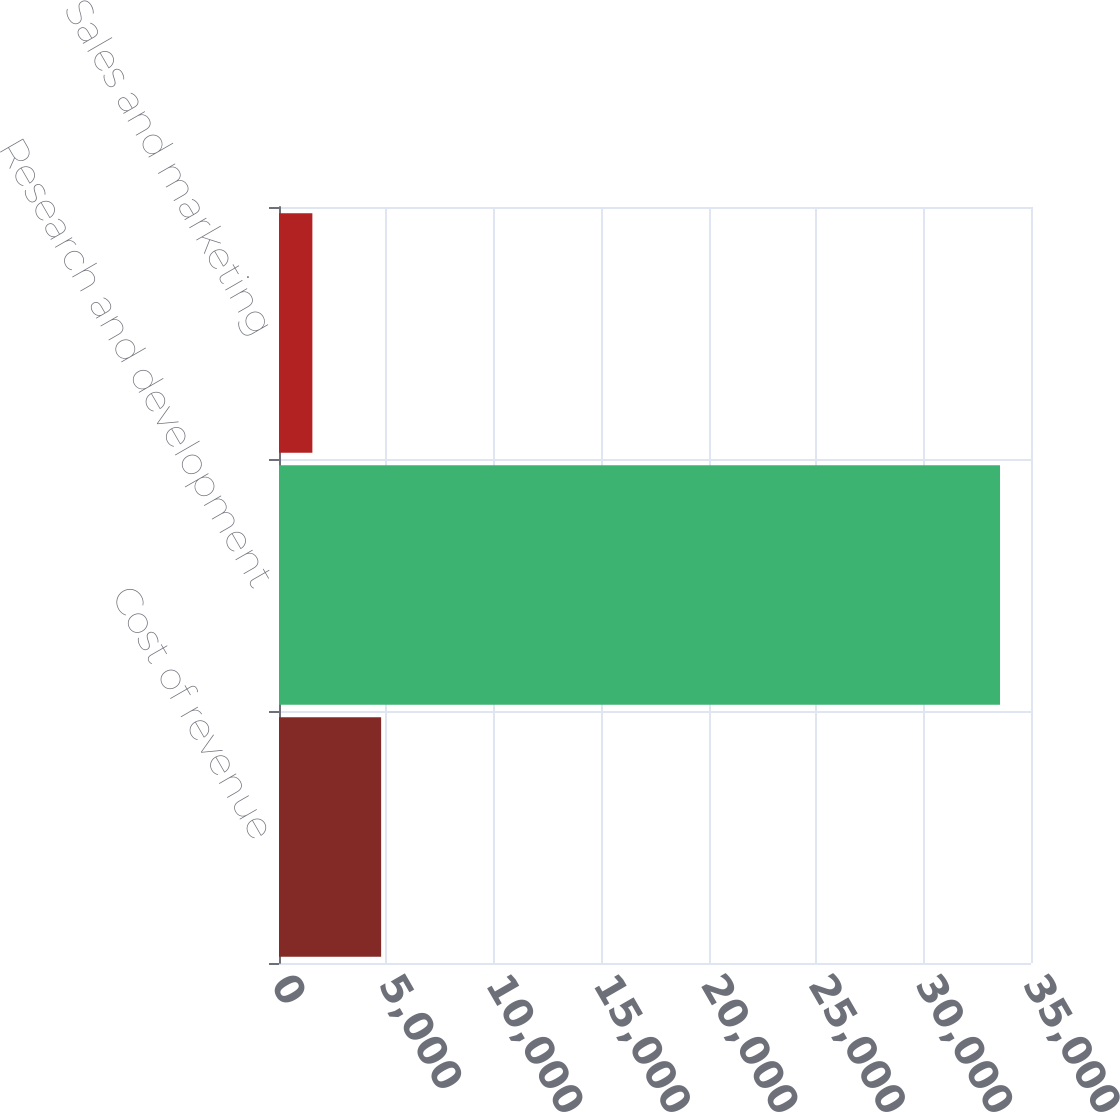<chart> <loc_0><loc_0><loc_500><loc_500><bar_chart><fcel>Cost of revenue<fcel>Research and development<fcel>Sales and marketing<nl><fcel>4753.6<fcel>33559<fcel>1553<nl></chart> 